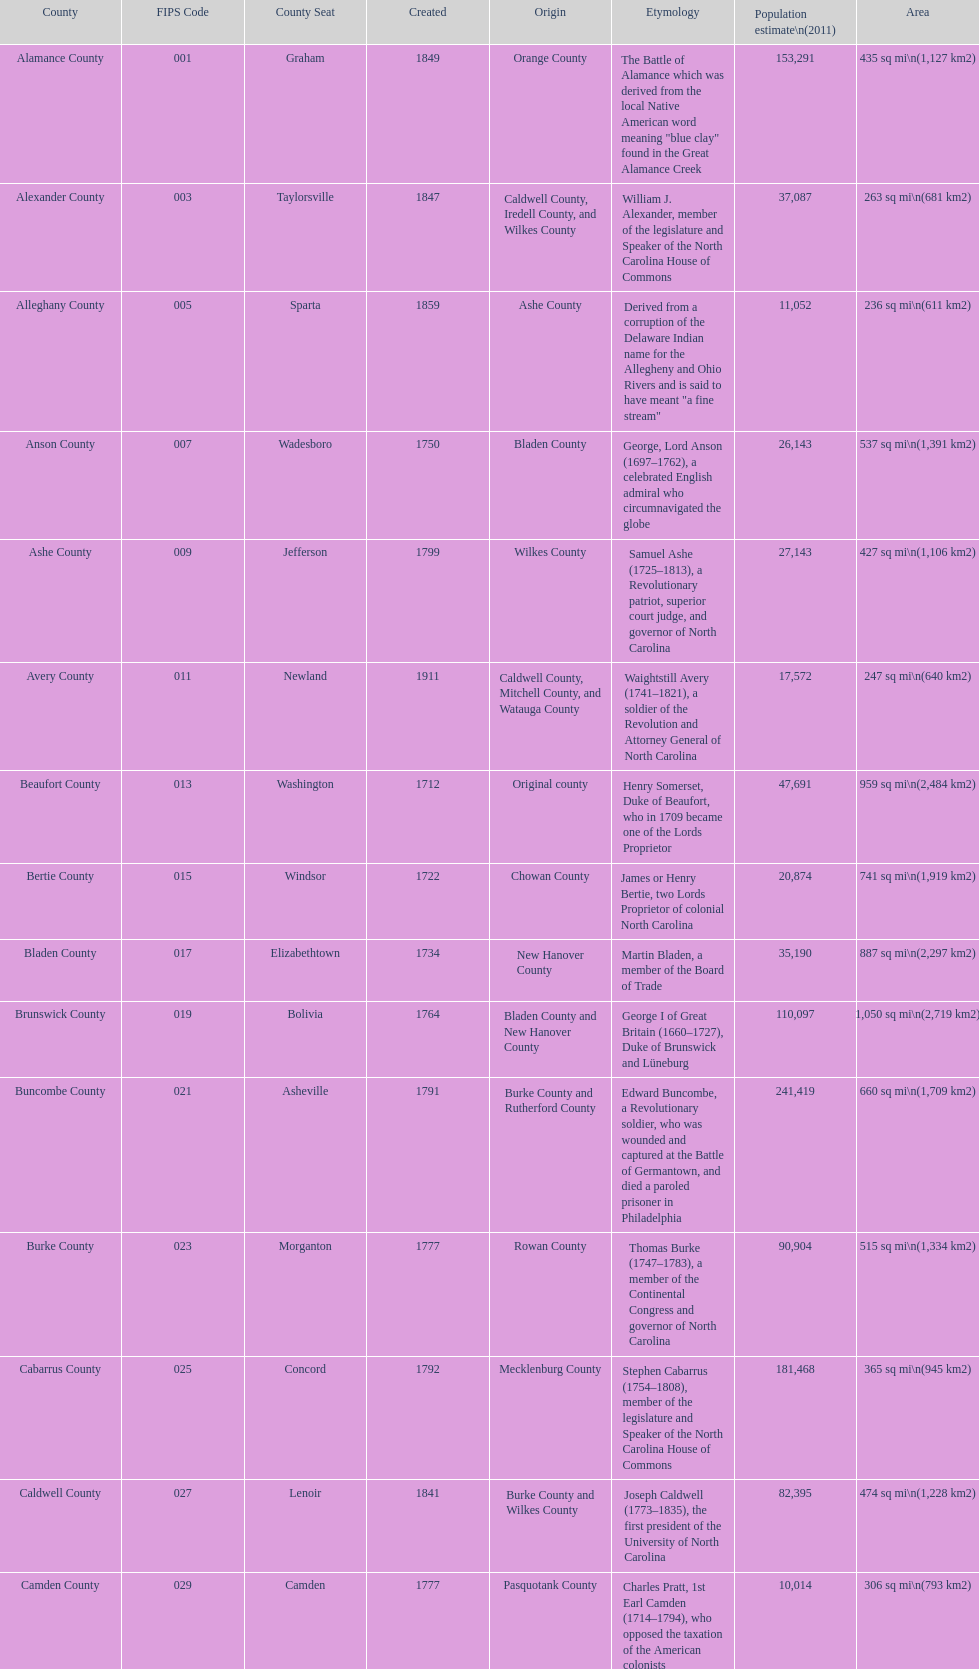What is the number of counties created in the 1800s? 37. 